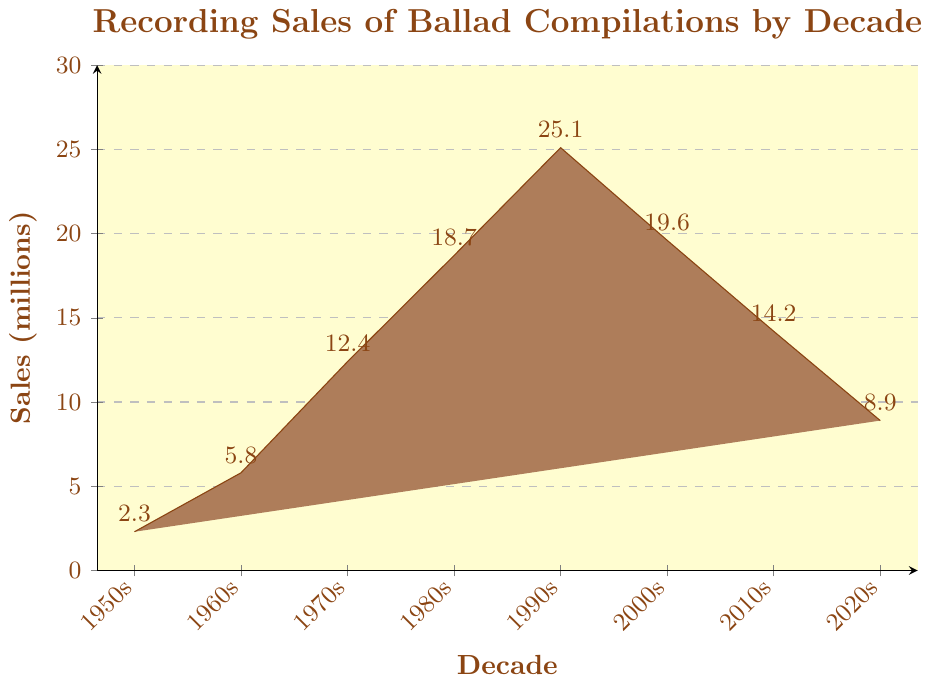Which decade had the highest recording sales of ballad compilations? From the figure, observe the height of the bars for each decade. The tallest bar represents the decade with the highest sales, which is the 1990s.
Answer: 1990s What is the difference in recording sales between the 1990s and the 2000s? Identify the sales values for the 1990s (25.1 million) and the 2000s (19.6 million). Subtract the sales of the 2000s from the sales of the 1990s: 25.1 - 19.6 = 5.5 million.
Answer: 5.5 million How did recording sales change from the 1950s to the 1970s? Look at the sales values for the 1950s (2.3 million) and the 1970s (12.4 million). Calculate the difference: 12.4 - 2.3 = 10.1 million. This shows an increase of 10.1 million.
Answer: Increased by 10.1 million Which decade saw the largest increase in sales compared to the previous decade? Compare the sales values between consecutive decades: 1960s-1950s (5.8 - 2.3 = 3.5), 1970s-1960s (12.4 - 5.8 = 6.6), 1980s-1970s (18.7 - 12.4 = 6.3), 1990s-1980s (25.1 - 18.7 = 6.4), 2000s-1990s (19.6 - 25.1 = -5.5), 2010s-2000s (14.2 - 19.6 = -5.4), 2020s-2010s (8.9 - 14.2 = -5.3). The largest increase is 6.6 million from the 1960s to the 1970s.
Answer: From the 1960s to the 1970s What is the average sales of ballad compilations from the 1950s to the 2020s? Add the sales values for all the decades and divide by the number of decades: (2.3 + 5.8 + 12.4 + 18.7 + 25.1 + 19.6 + 14.2 + 8.9)/8 = 13.75 million.
Answer: 13.75 million Did recording sales increase or decrease from the 2010s to the 2020s? Compare the heights of the bars for the 2010s (14.2 million) and the 2020s (8.9 million). The bar for the 2020s is shorter, indicating a decrease.
Answer: Decrease Which decade saw a peak in sales followed by consecutive declines? Identify the decade with the highest bar followed by bars that continuously decrease. The peak decade is the 1990s (25.1 million), followed by declines in the 2000s (19.6 million), 2010s (14.2 million), and 2020s (8.9 million).
Answer: 1990s What is the total sales value for the decades 1980s and 1990s combined? Sum the sales values for the 1980s and 1990s: 18.7 + 25.1 = 43.8 million.
Answer: 43.8 million 